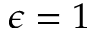Convert formula to latex. <formula><loc_0><loc_0><loc_500><loc_500>\epsilon = 1</formula> 